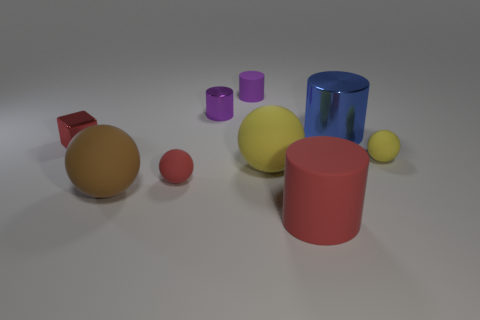Subtract all red rubber spheres. How many spheres are left? 3 Subtract all gray spheres. How many purple cylinders are left? 2 Subtract all red spheres. How many spheres are left? 3 Subtract 2 cylinders. How many cylinders are left? 2 Add 1 red shiny cylinders. How many objects exist? 10 Subtract all yellow cylinders. Subtract all brown spheres. How many cylinders are left? 4 Subtract all blocks. How many objects are left? 8 Subtract all tiny purple cylinders. Subtract all large shiny cylinders. How many objects are left? 6 Add 6 purple metal objects. How many purple metal objects are left? 7 Add 2 large green cylinders. How many large green cylinders exist? 2 